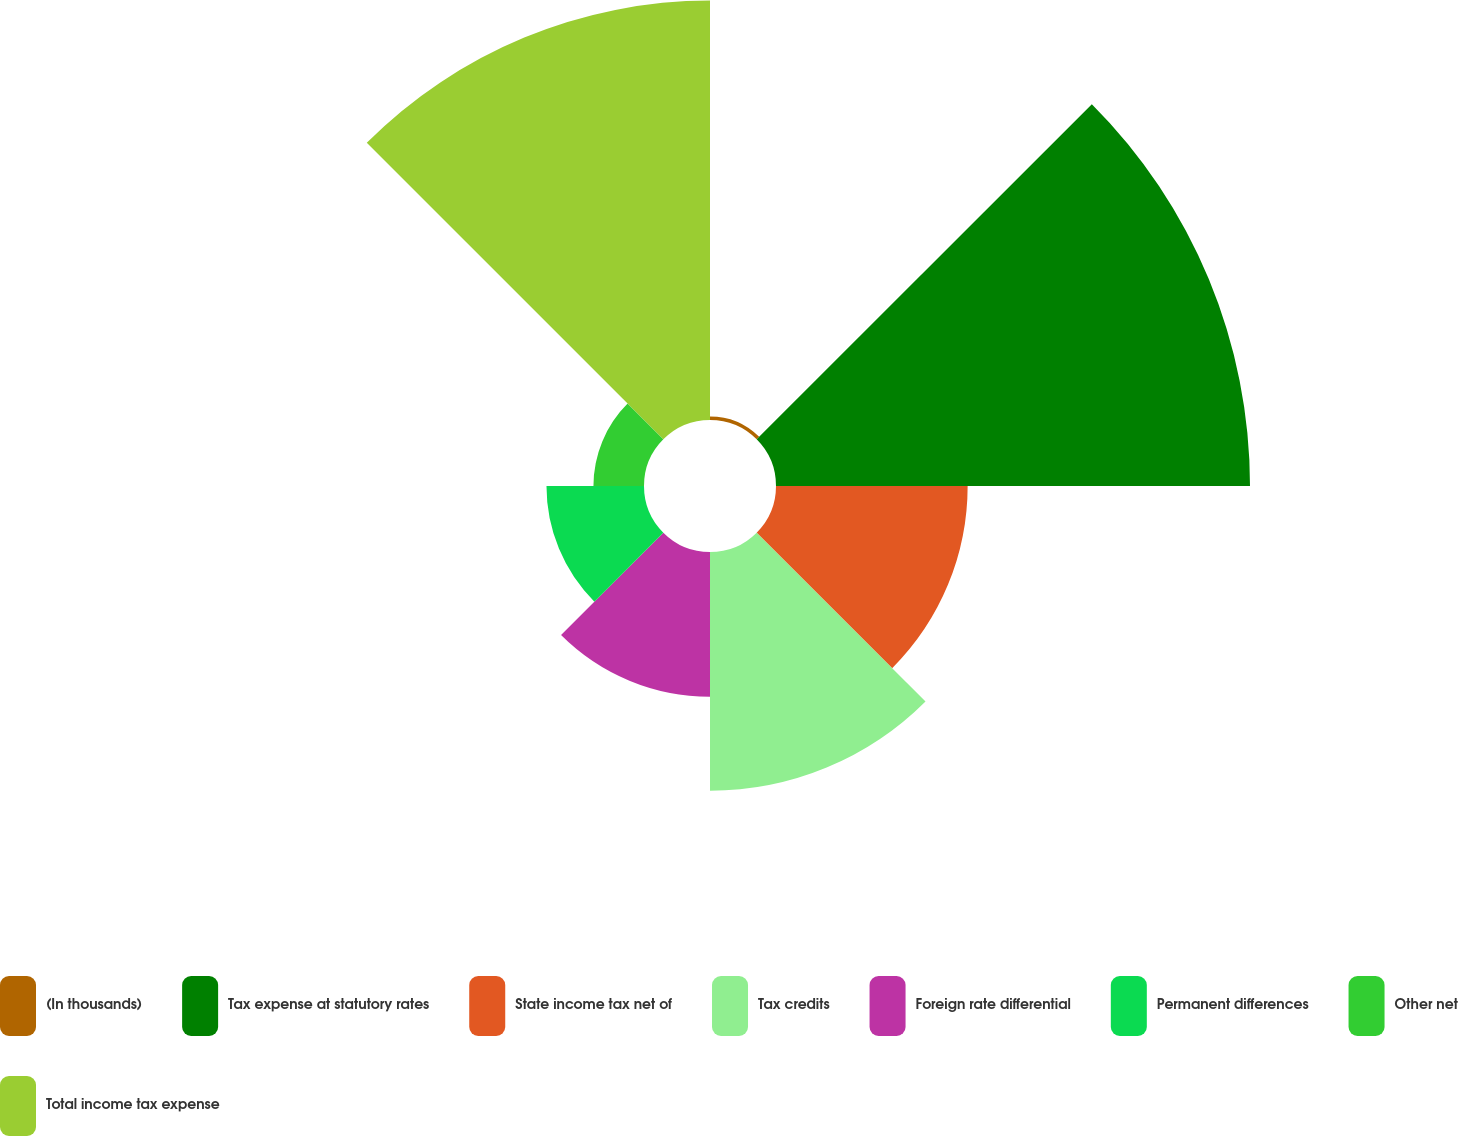<chart> <loc_0><loc_0><loc_500><loc_500><pie_chart><fcel>(In thousands)<fcel>Tax expense at statutory rates<fcel>State income tax net of<fcel>Tax credits<fcel>Foreign rate differential<fcel>Permanent differences<fcel>Other net<fcel>Total income tax expense<nl><fcel>0.22%<fcel>29.26%<fcel>11.83%<fcel>14.74%<fcel>8.93%<fcel>6.02%<fcel>3.12%<fcel>25.89%<nl></chart> 